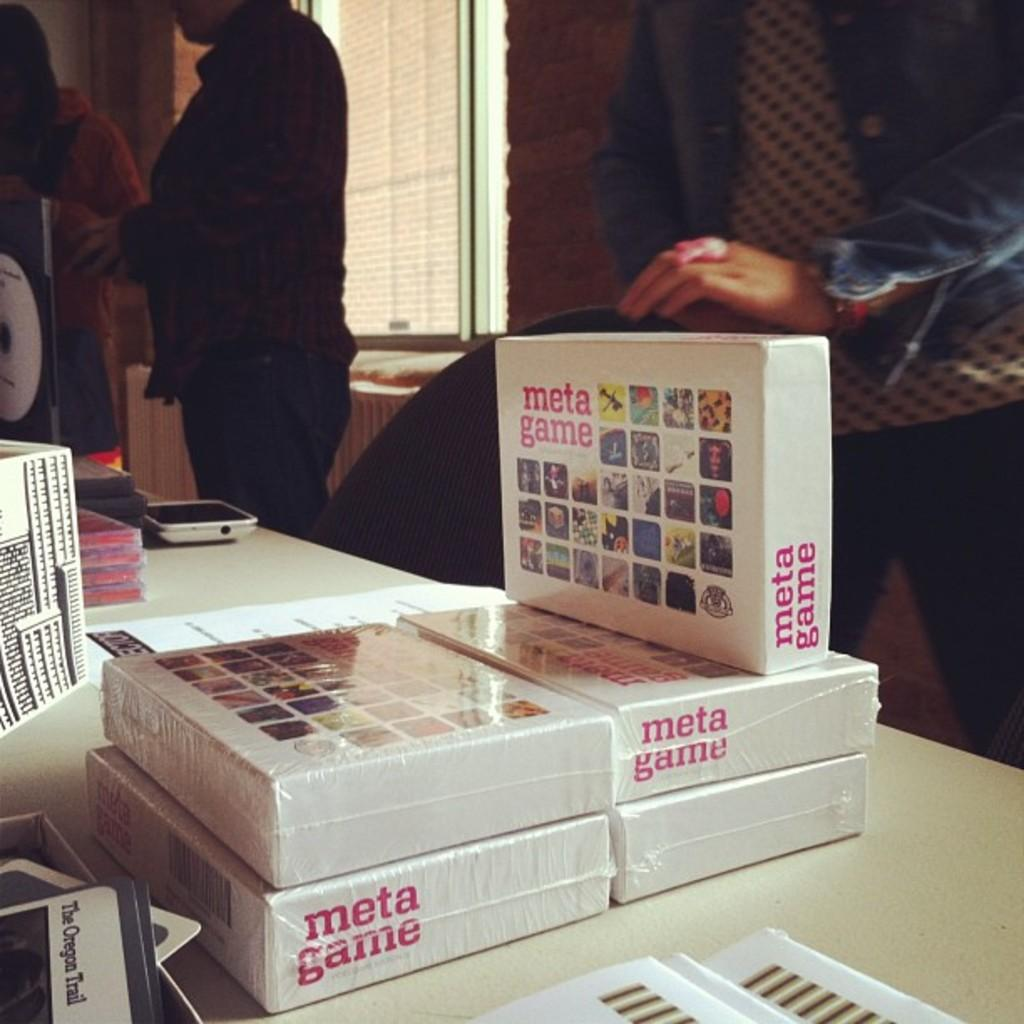What objects are present in the image that are used for storage? There are boxes in the image that are used for storage. What is on the table in the image? There is a mobile on a table in the image. What type of furniture is in the image? There is a chair in the image. How many people are in the image? Three people are standing in the image. What can be seen in the background of the image? There is a window visible in the background of the image. What type of game is being played in the image? There is no game being played in the image; it only shows boxes, a mobile, a chair, three people, and a window. 